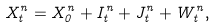Convert formula to latex. <formula><loc_0><loc_0><loc_500><loc_500>X ^ { n } _ { t } = X ^ { n } _ { 0 } + I ^ { n } _ { t } + J ^ { n } _ { t } + W ^ { n } _ { t } ,</formula> 